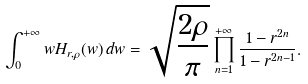Convert formula to latex. <formula><loc_0><loc_0><loc_500><loc_500>\int _ { 0 } ^ { + \infty } w H _ { r , \rho } ( w ) \, d w = \sqrt { \frac { 2 \rho } { \pi } } \prod _ { n = 1 } ^ { + \infty } \frac { 1 - r ^ { 2 n } } { 1 - r ^ { 2 n - 1 } } .</formula> 